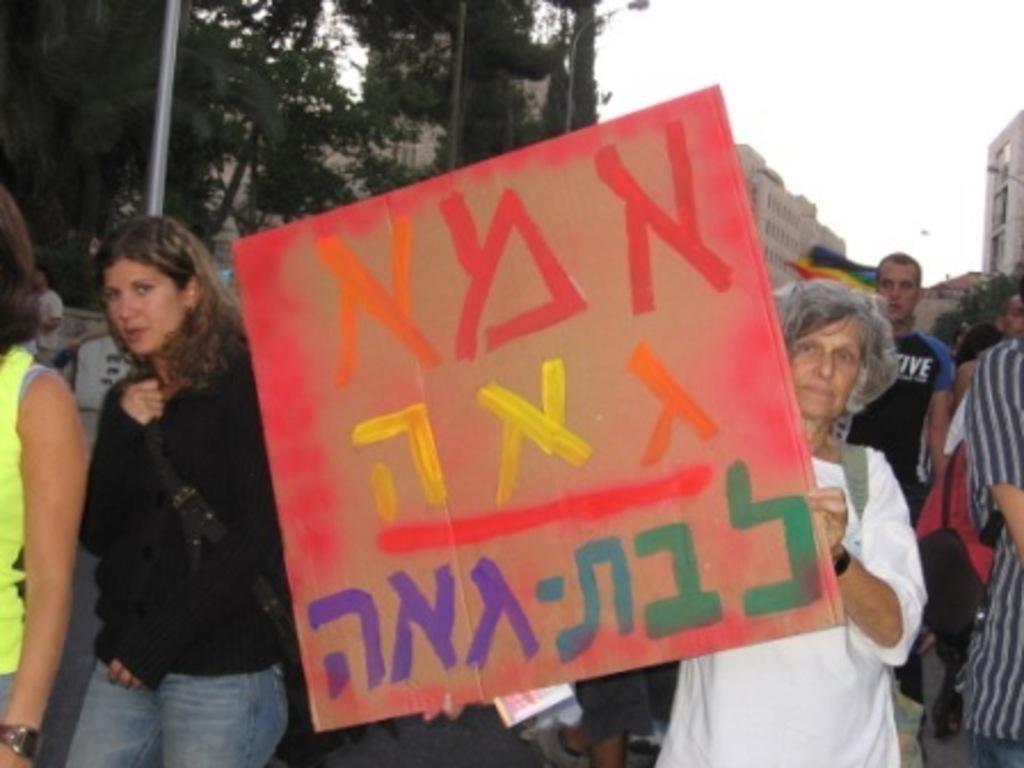How would you summarize this image in a sentence or two? A woman is holding a board. Background there are buildings, light poles, trees, flag and people. 